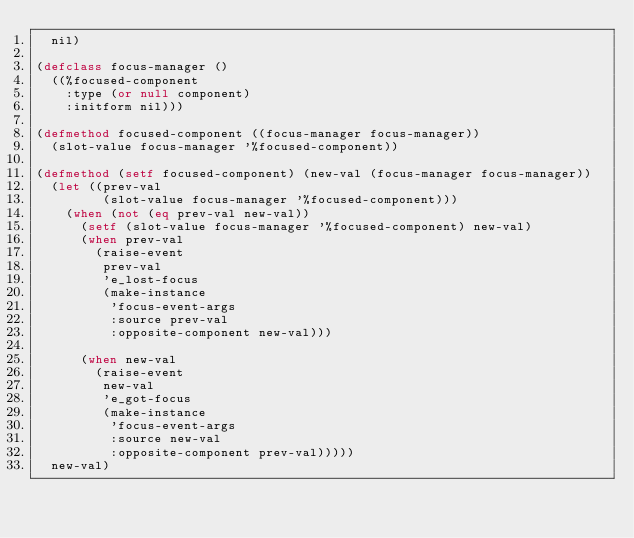Convert code to text. <code><loc_0><loc_0><loc_500><loc_500><_Lisp_>  nil)

(defclass focus-manager ()
  ((%focused-component
    :type (or null component)
    :initform nil)))

(defmethod focused-component ((focus-manager focus-manager))
  (slot-value focus-manager '%focused-component))

(defmethod (setf focused-component) (new-val (focus-manager focus-manager))
  (let ((prev-val
         (slot-value focus-manager '%focused-component)))
    (when (not (eq prev-val new-val))
      (setf (slot-value focus-manager '%focused-component) new-val)
      (when prev-val
        (raise-event
         prev-val
         'e_lost-focus
         (make-instance
          'focus-event-args
          :source prev-val
          :opposite-component new-val)))

      (when new-val
        (raise-event
         new-val
         'e_got-focus
         (make-instance
          'focus-event-args
          :source new-val
          :opposite-component prev-val)))))
  new-val)
</code> 